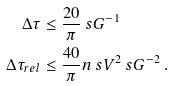<formula> <loc_0><loc_0><loc_500><loc_500>\Delta \tau & \leq \frac { 2 0 } { \pi } \ s G ^ { - 1 } \\ \Delta \tau _ { r e l } & \leq \frac { 4 0 } { \pi } n \ s V ^ { 2 } \ s G ^ { - 2 } \, .</formula> 